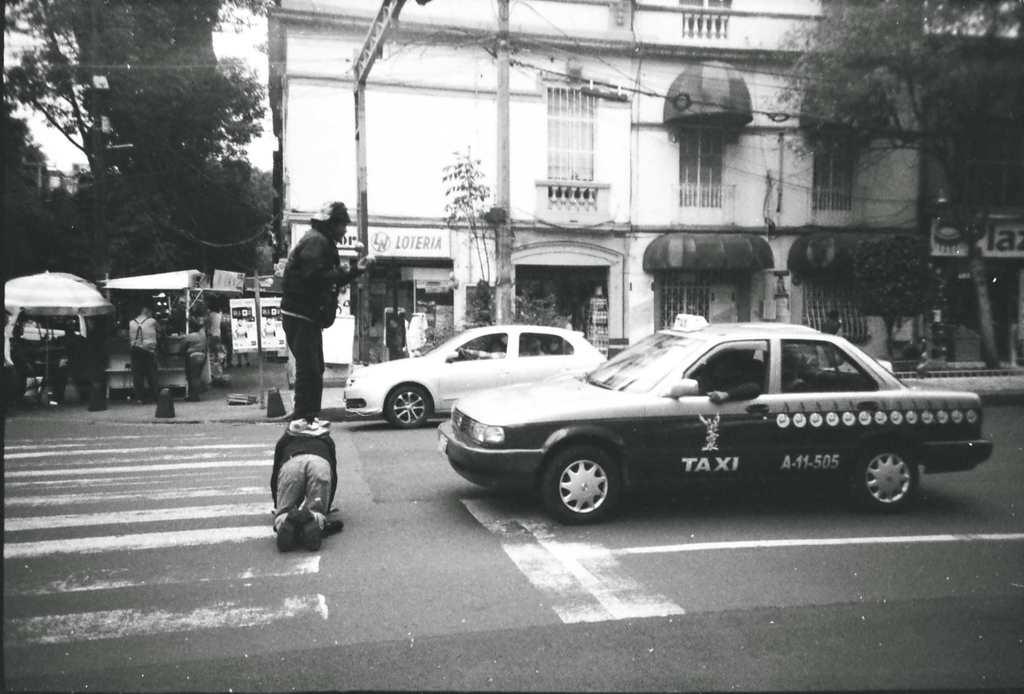What type of car is this?
Provide a short and direct response. Taxi. What is the number of the taxi?
Keep it short and to the point. A-11-505. 